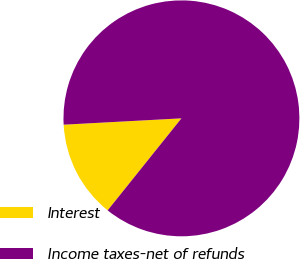Convert chart to OTSL. <chart><loc_0><loc_0><loc_500><loc_500><pie_chart><fcel>Interest<fcel>Income taxes-net of refunds<nl><fcel>13.39%<fcel>86.61%<nl></chart> 